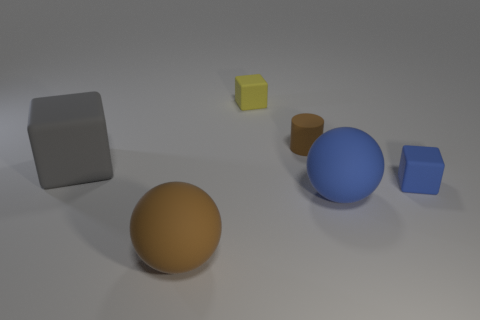How big is the cube that is both in front of the yellow thing and right of the big brown sphere?
Offer a terse response. Small. How many other things are the same color as the rubber cylinder?
Provide a short and direct response. 1. What is the size of the object that is to the right of the big thing on the right side of the small brown thing that is on the right side of the big gray thing?
Your response must be concise. Small. There is a tiny yellow matte thing; are there any blue balls behind it?
Give a very brief answer. No. There is a blue block; does it have the same size as the matte ball right of the rubber cylinder?
Provide a succinct answer. No. How many other things are the same material as the tiny blue object?
Your answer should be very brief. 5. The large thing that is right of the large matte cube and on the left side of the small yellow matte object has what shape?
Give a very brief answer. Sphere. Is the size of the blue block right of the blue ball the same as the brown matte thing behind the brown matte sphere?
Your answer should be very brief. Yes. There is a yellow object that is the same material as the big gray thing; what is its shape?
Ensure brevity in your answer.  Cube. Is there any other thing that has the same shape as the small brown matte object?
Offer a very short reply. No. 